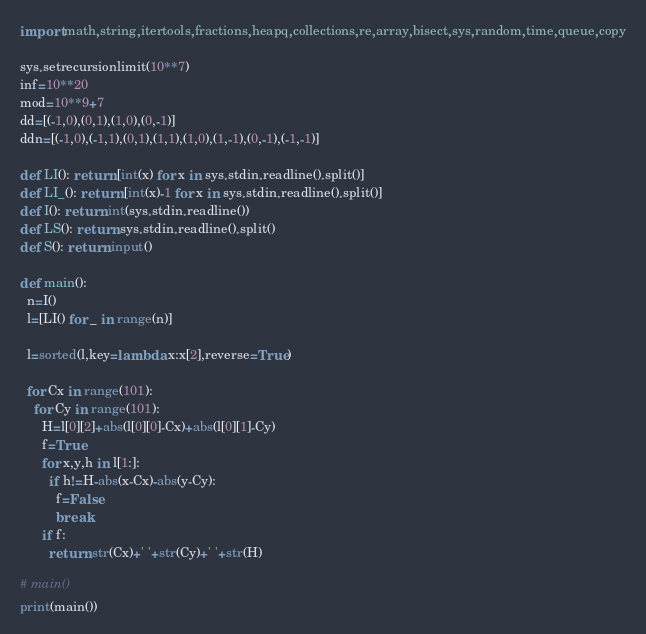<code> <loc_0><loc_0><loc_500><loc_500><_Python_>import math,string,itertools,fractions,heapq,collections,re,array,bisect,sys,random,time,queue,copy

sys.setrecursionlimit(10**7)
inf=10**20
mod=10**9+7
dd=[(-1,0),(0,1),(1,0),(0,-1)]
ddn=[(-1,0),(-1,1),(0,1),(1,1),(1,0),(1,-1),(0,-1),(-1,-1)]

def LI(): return [int(x) for x in sys.stdin.readline().split()]
def LI_(): return [int(x)-1 for x in sys.stdin.readline().split()]
def I(): return int(sys.stdin.readline())
def LS(): return sys.stdin.readline().split()
def S(): return input()

def main():
  n=I()
  l=[LI() for _ in range(n)]

  l=sorted(l,key=lambda x:x[2],reverse=True)

  for Cx in range(101):
    for Cy in range(101):
      H=l[0][2]+abs(l[0][0]-Cx)+abs(l[0][1]-Cy)
      f=True
      for x,y,h in l[1:]:
        if h!=H-abs(x-Cx)-abs(y-Cy):
          f=False
          break
      if f:
        return str(Cx)+' '+str(Cy)+' '+str(H)

# main()
print(main())
</code> 